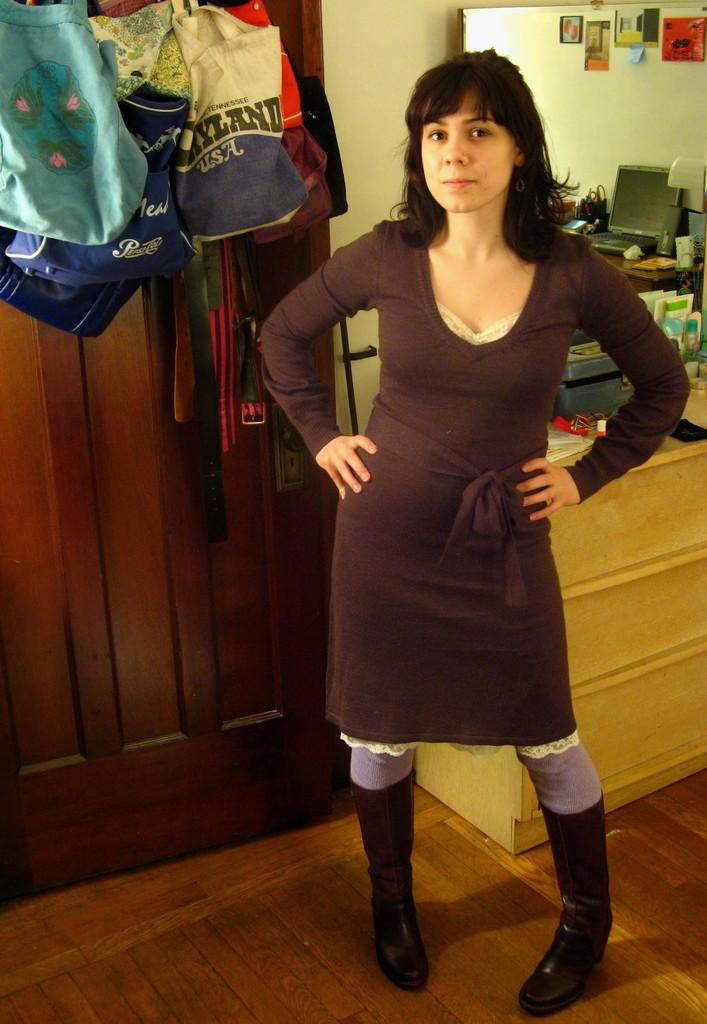<image>
Summarize the visual content of the image. A woman in a brown dress is standing with her hands on her hip and behind her is a blue and white bag with USA on it. 